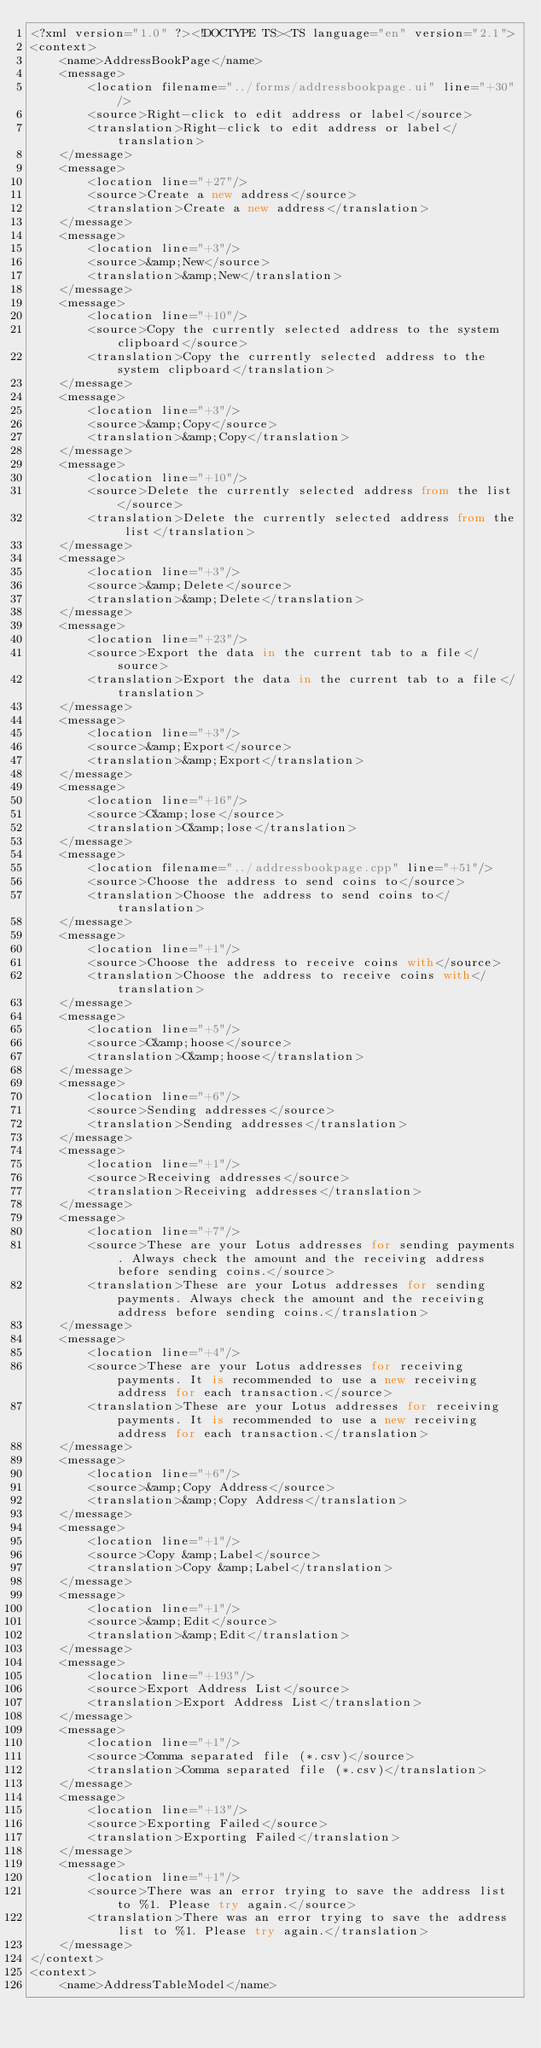<code> <loc_0><loc_0><loc_500><loc_500><_TypeScript_><?xml version="1.0" ?><!DOCTYPE TS><TS language="en" version="2.1">
<context>
    <name>AddressBookPage</name>
    <message>
        <location filename="../forms/addressbookpage.ui" line="+30"/>
        <source>Right-click to edit address or label</source>
        <translation>Right-click to edit address or label</translation>
    </message>
    <message>
        <location line="+27"/>
        <source>Create a new address</source>
        <translation>Create a new address</translation>
    </message>
    <message>
        <location line="+3"/>
        <source>&amp;New</source>
        <translation>&amp;New</translation>
    </message>
    <message>
        <location line="+10"/>
        <source>Copy the currently selected address to the system clipboard</source>
        <translation>Copy the currently selected address to the system clipboard</translation>
    </message>
    <message>
        <location line="+3"/>
        <source>&amp;Copy</source>
        <translation>&amp;Copy</translation>
    </message>
    <message>
        <location line="+10"/>
        <source>Delete the currently selected address from the list</source>
        <translation>Delete the currently selected address from the list</translation>
    </message>
    <message>
        <location line="+3"/>
        <source>&amp;Delete</source>
        <translation>&amp;Delete</translation>
    </message>
    <message>
        <location line="+23"/>
        <source>Export the data in the current tab to a file</source>
        <translation>Export the data in the current tab to a file</translation>
    </message>
    <message>
        <location line="+3"/>
        <source>&amp;Export</source>
        <translation>&amp;Export</translation>
    </message>
    <message>
        <location line="+16"/>
        <source>C&amp;lose</source>
        <translation>C&amp;lose</translation>
    </message>
    <message>
        <location filename="../addressbookpage.cpp" line="+51"/>
        <source>Choose the address to send coins to</source>
        <translation>Choose the address to send coins to</translation>
    </message>
    <message>
        <location line="+1"/>
        <source>Choose the address to receive coins with</source>
        <translation>Choose the address to receive coins with</translation>
    </message>
    <message>
        <location line="+5"/>
        <source>C&amp;hoose</source>
        <translation>C&amp;hoose</translation>
    </message>
    <message>
        <location line="+6"/>
        <source>Sending addresses</source>
        <translation>Sending addresses</translation>
    </message>
    <message>
        <location line="+1"/>
        <source>Receiving addresses</source>
        <translation>Receiving addresses</translation>
    </message>
    <message>
        <location line="+7"/>
        <source>These are your Lotus addresses for sending payments. Always check the amount and the receiving address before sending coins.</source>
        <translation>These are your Lotus addresses for sending payments. Always check the amount and the receiving address before sending coins.</translation>
    </message>
    <message>
        <location line="+4"/>
        <source>These are your Lotus addresses for receiving payments. It is recommended to use a new receiving address for each transaction.</source>
        <translation>These are your Lotus addresses for receiving payments. It is recommended to use a new receiving address for each transaction.</translation>
    </message>
    <message>
        <location line="+6"/>
        <source>&amp;Copy Address</source>
        <translation>&amp;Copy Address</translation>
    </message>
    <message>
        <location line="+1"/>
        <source>Copy &amp;Label</source>
        <translation>Copy &amp;Label</translation>
    </message>
    <message>
        <location line="+1"/>
        <source>&amp;Edit</source>
        <translation>&amp;Edit</translation>
    </message>
    <message>
        <location line="+193"/>
        <source>Export Address List</source>
        <translation>Export Address List</translation>
    </message>
    <message>
        <location line="+1"/>
        <source>Comma separated file (*.csv)</source>
        <translation>Comma separated file (*.csv)</translation>
    </message>
    <message>
        <location line="+13"/>
        <source>Exporting Failed</source>
        <translation>Exporting Failed</translation>
    </message>
    <message>
        <location line="+1"/>
        <source>There was an error trying to save the address list to %1. Please try again.</source>
        <translation>There was an error trying to save the address list to %1. Please try again.</translation>
    </message>
</context>
<context>
    <name>AddressTableModel</name></code> 